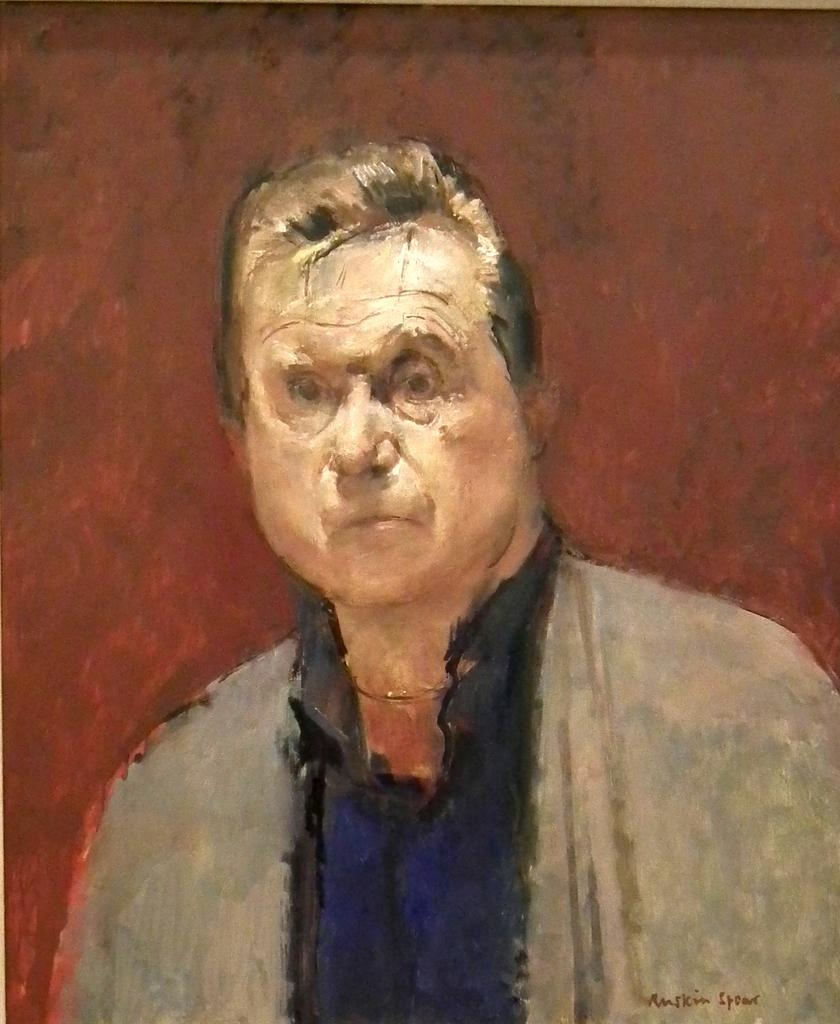What is the main subject of the image? The image contains a painting. What is the person in the painting wearing? The person in the painting is wearing a coat. What color is the background of the painting? The background of the painting is maroon in color. Can you tell me how many books are on the shelf in the painting? There is no shelf or books visible in the painting; it depicts a person wearing a coat with a maroon background. 